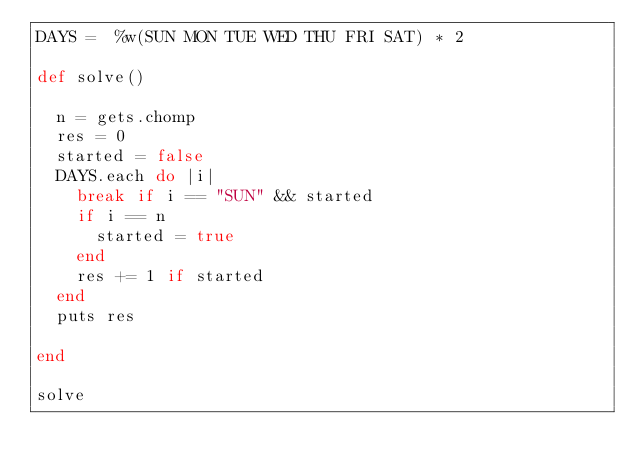<code> <loc_0><loc_0><loc_500><loc_500><_Ruby_>DAYS =  %w(SUN MON TUE WED THU FRI SAT) * 2

def solve()

  n = gets.chomp
  res = 0
  started = false
  DAYS.each do |i|
    break if i == "SUN" && started
    if i == n
      started = true
    end
    res += 1 if started
  end
  puts res
  
end

solve</code> 